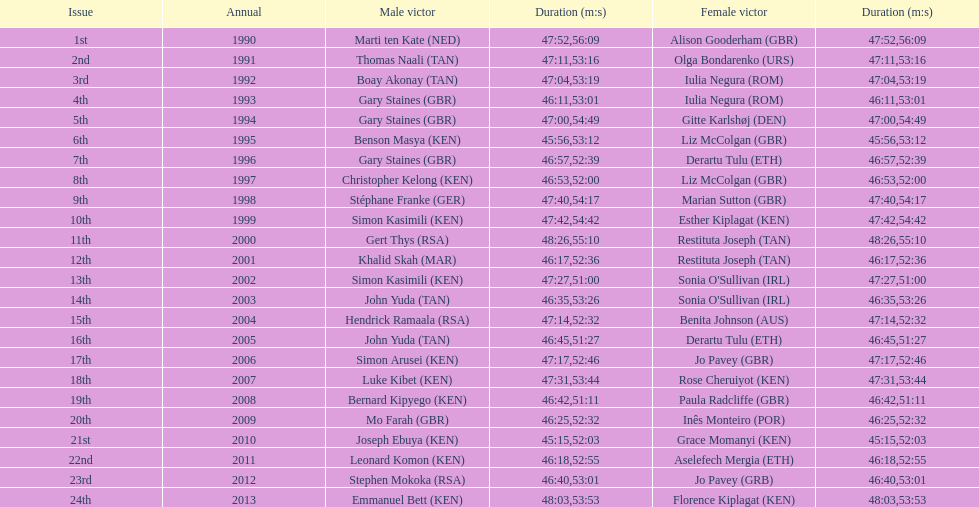What is the difference in finishing times for the men's and women's bupa great south run finish for 2013? 5:50. 